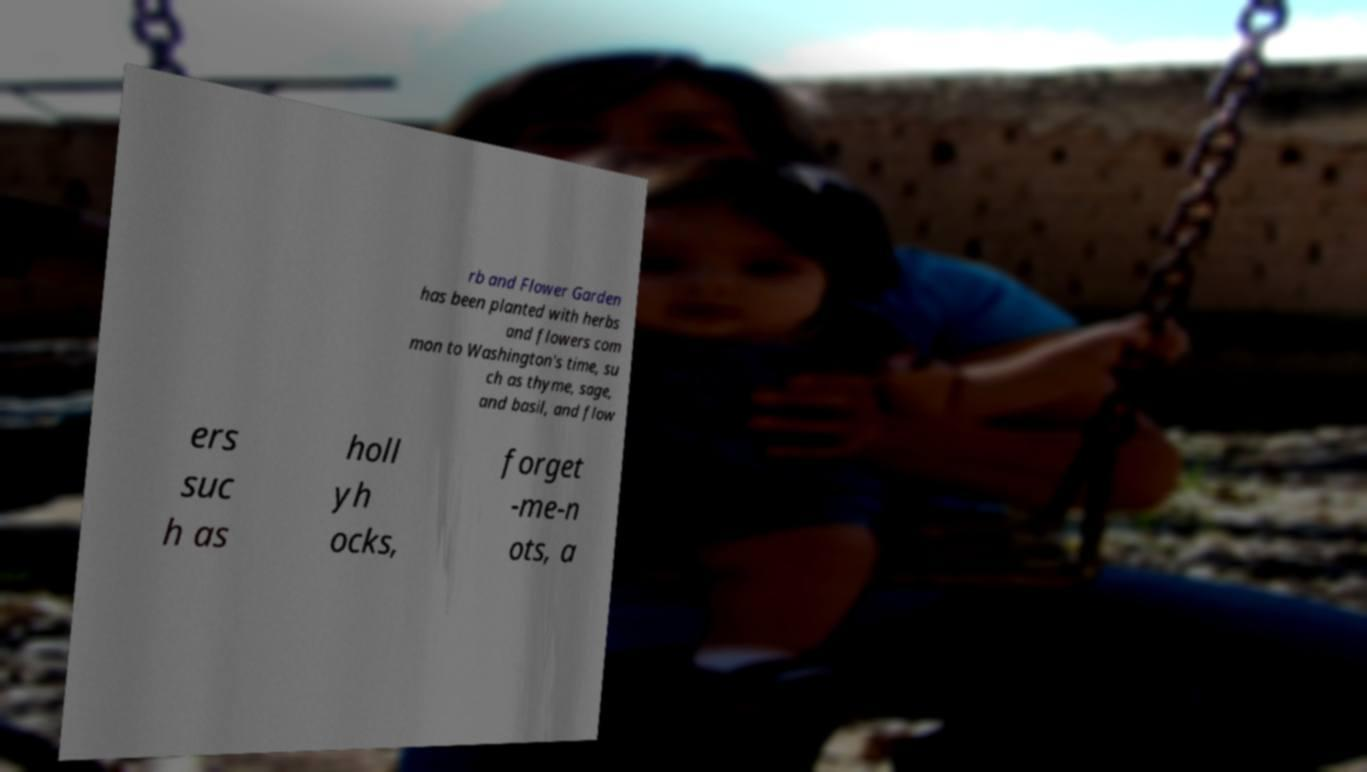I need the written content from this picture converted into text. Can you do that? rb and Flower Garden has been planted with herbs and flowers com mon to Washington's time, su ch as thyme, sage, and basil, and flow ers suc h as holl yh ocks, forget -me-n ots, a 